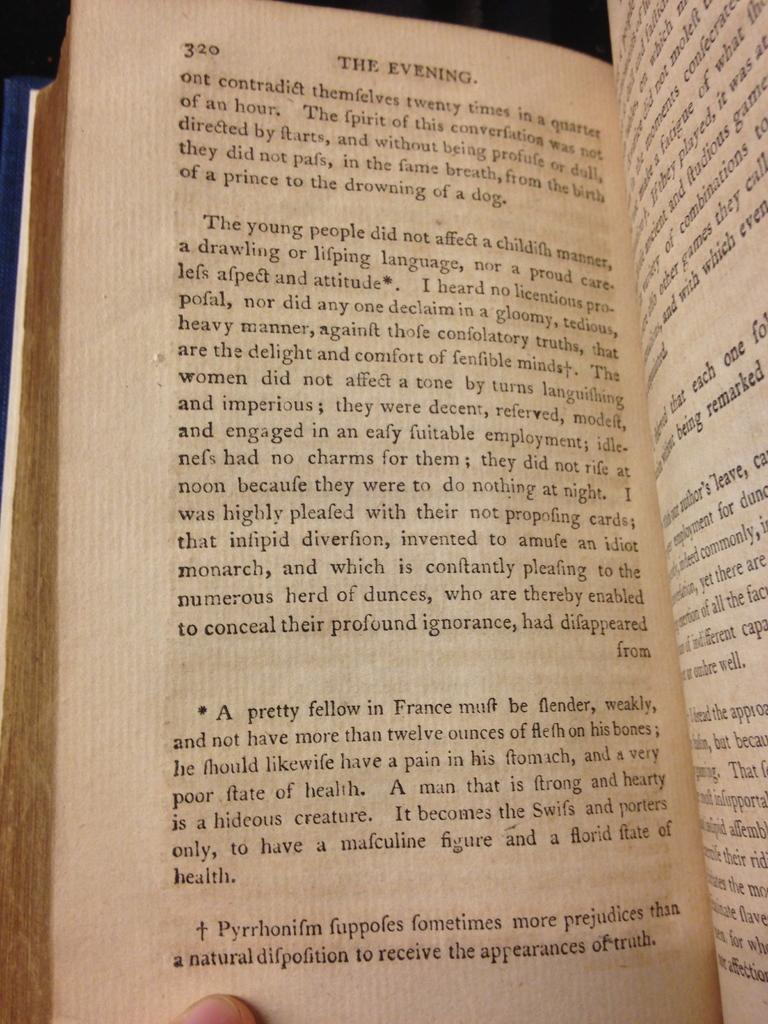<image>
Offer a succinct explanation of the picture presented. two pages of a book from the chapter called the evening. 